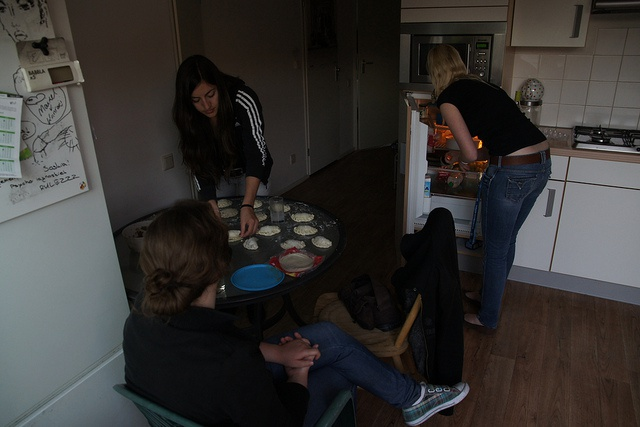Describe the objects in this image and their specific colors. I can see refrigerator in black and gray tones, people in black, maroon, and gray tones, people in black, maroon, and brown tones, people in black, maroon, and gray tones, and dining table in black, gray, darkblue, and maroon tones in this image. 